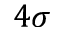<formula> <loc_0><loc_0><loc_500><loc_500>4 \sigma</formula> 